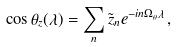<formula> <loc_0><loc_0><loc_500><loc_500>\cos \theta _ { z } ( \lambda ) = \sum _ { n } \tilde { z } _ { n } e ^ { - i n \Omega _ { \theta } \lambda } \, ,</formula> 